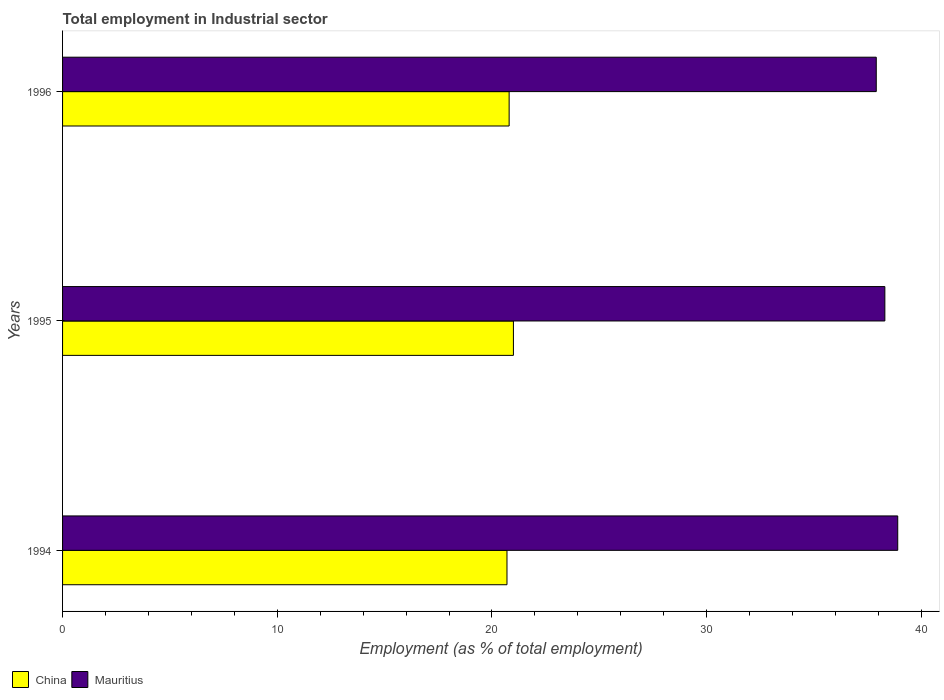How many bars are there on the 3rd tick from the bottom?
Provide a short and direct response. 2. What is the label of the 2nd group of bars from the top?
Your answer should be very brief. 1995. What is the employment in industrial sector in Mauritius in 1994?
Offer a very short reply. 38.9. Across all years, what is the minimum employment in industrial sector in Mauritius?
Give a very brief answer. 37.9. In which year was the employment in industrial sector in Mauritius maximum?
Provide a succinct answer. 1994. In which year was the employment in industrial sector in China minimum?
Keep it short and to the point. 1994. What is the total employment in industrial sector in China in the graph?
Provide a short and direct response. 62.5. What is the difference between the employment in industrial sector in China in 1995 and that in 1996?
Offer a very short reply. 0.2. What is the difference between the employment in industrial sector in Mauritius in 1996 and the employment in industrial sector in China in 1995?
Ensure brevity in your answer.  16.9. What is the average employment in industrial sector in Mauritius per year?
Your answer should be very brief. 38.37. In the year 1994, what is the difference between the employment in industrial sector in Mauritius and employment in industrial sector in China?
Offer a terse response. 18.2. In how many years, is the employment in industrial sector in China greater than 14 %?
Make the answer very short. 3. What is the ratio of the employment in industrial sector in Mauritius in 1994 to that in 1995?
Your answer should be very brief. 1.02. What is the difference between the highest and the second highest employment in industrial sector in Mauritius?
Offer a very short reply. 0.6. What does the 1st bar from the top in 1994 represents?
Offer a very short reply. Mauritius. What does the 2nd bar from the bottom in 1994 represents?
Your response must be concise. Mauritius. How many bars are there?
Ensure brevity in your answer.  6. Are all the bars in the graph horizontal?
Make the answer very short. Yes. Does the graph contain any zero values?
Your response must be concise. No. Does the graph contain grids?
Keep it short and to the point. No. What is the title of the graph?
Provide a succinct answer. Total employment in Industrial sector. What is the label or title of the X-axis?
Ensure brevity in your answer.  Employment (as % of total employment). What is the label or title of the Y-axis?
Provide a short and direct response. Years. What is the Employment (as % of total employment) of China in 1994?
Make the answer very short. 20.7. What is the Employment (as % of total employment) of Mauritius in 1994?
Ensure brevity in your answer.  38.9. What is the Employment (as % of total employment) of Mauritius in 1995?
Your response must be concise. 38.3. What is the Employment (as % of total employment) in China in 1996?
Provide a succinct answer. 20.8. What is the Employment (as % of total employment) in Mauritius in 1996?
Provide a short and direct response. 37.9. Across all years, what is the maximum Employment (as % of total employment) of Mauritius?
Your response must be concise. 38.9. Across all years, what is the minimum Employment (as % of total employment) in China?
Your answer should be very brief. 20.7. Across all years, what is the minimum Employment (as % of total employment) in Mauritius?
Your response must be concise. 37.9. What is the total Employment (as % of total employment) of China in the graph?
Provide a short and direct response. 62.5. What is the total Employment (as % of total employment) in Mauritius in the graph?
Provide a short and direct response. 115.1. What is the difference between the Employment (as % of total employment) in China in 1994 and that in 1995?
Your answer should be compact. -0.3. What is the difference between the Employment (as % of total employment) in China in 1994 and the Employment (as % of total employment) in Mauritius in 1995?
Give a very brief answer. -17.6. What is the difference between the Employment (as % of total employment) of China in 1994 and the Employment (as % of total employment) of Mauritius in 1996?
Your answer should be compact. -17.2. What is the difference between the Employment (as % of total employment) in China in 1995 and the Employment (as % of total employment) in Mauritius in 1996?
Provide a short and direct response. -16.9. What is the average Employment (as % of total employment) in China per year?
Provide a succinct answer. 20.83. What is the average Employment (as % of total employment) of Mauritius per year?
Your answer should be very brief. 38.37. In the year 1994, what is the difference between the Employment (as % of total employment) in China and Employment (as % of total employment) in Mauritius?
Ensure brevity in your answer.  -18.2. In the year 1995, what is the difference between the Employment (as % of total employment) in China and Employment (as % of total employment) in Mauritius?
Your answer should be very brief. -17.3. In the year 1996, what is the difference between the Employment (as % of total employment) in China and Employment (as % of total employment) in Mauritius?
Your answer should be compact. -17.1. What is the ratio of the Employment (as % of total employment) in China in 1994 to that in 1995?
Offer a very short reply. 0.99. What is the ratio of the Employment (as % of total employment) of Mauritius in 1994 to that in 1995?
Your answer should be very brief. 1.02. What is the ratio of the Employment (as % of total employment) in Mauritius in 1994 to that in 1996?
Your response must be concise. 1.03. What is the ratio of the Employment (as % of total employment) in China in 1995 to that in 1996?
Give a very brief answer. 1.01. What is the ratio of the Employment (as % of total employment) of Mauritius in 1995 to that in 1996?
Offer a terse response. 1.01. What is the difference between the highest and the second highest Employment (as % of total employment) of Mauritius?
Your answer should be compact. 0.6. What is the difference between the highest and the lowest Employment (as % of total employment) in Mauritius?
Your answer should be very brief. 1. 